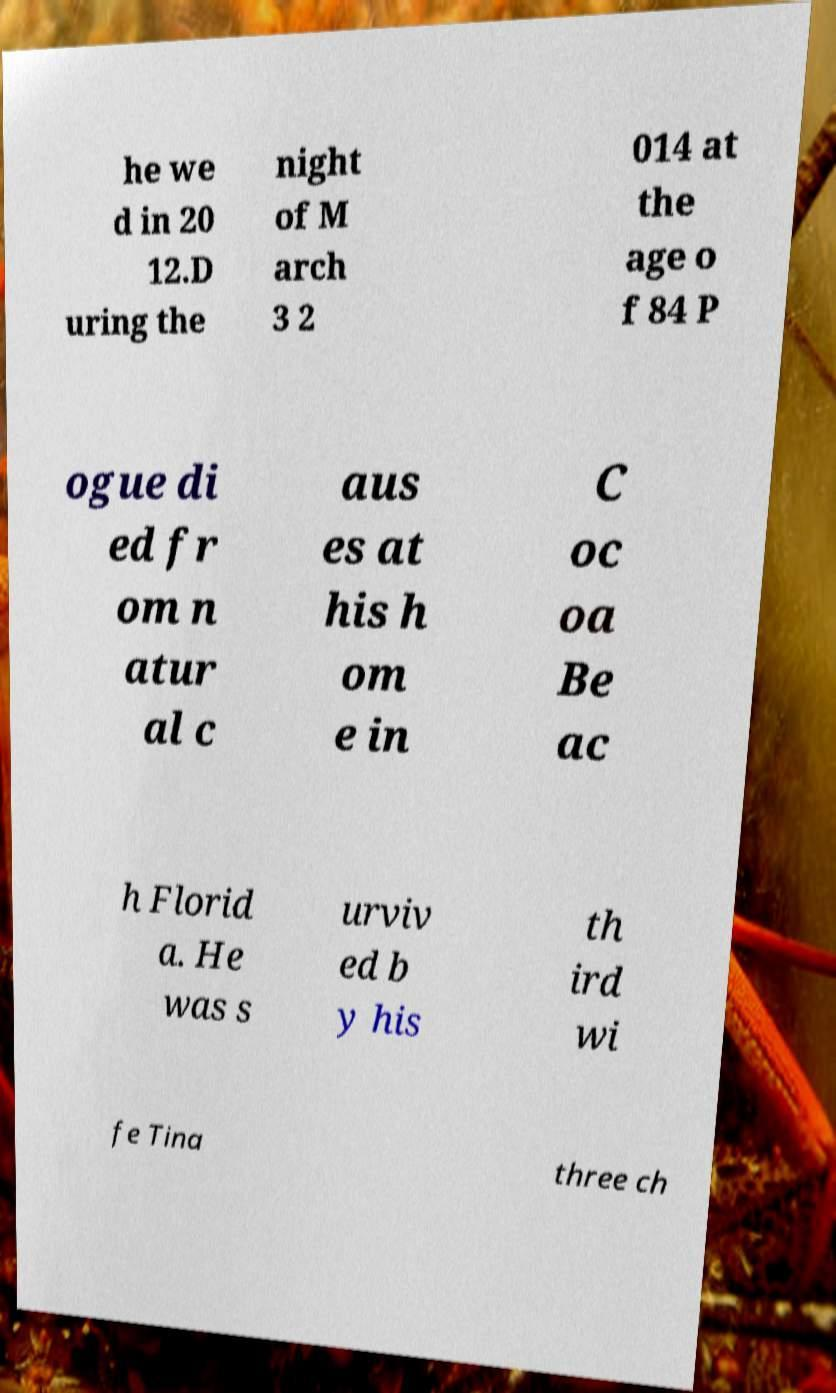I need the written content from this picture converted into text. Can you do that? he we d in 20 12.D uring the night of M arch 3 2 014 at the age o f 84 P ogue di ed fr om n atur al c aus es at his h om e in C oc oa Be ac h Florid a. He was s urviv ed b y his th ird wi fe Tina three ch 